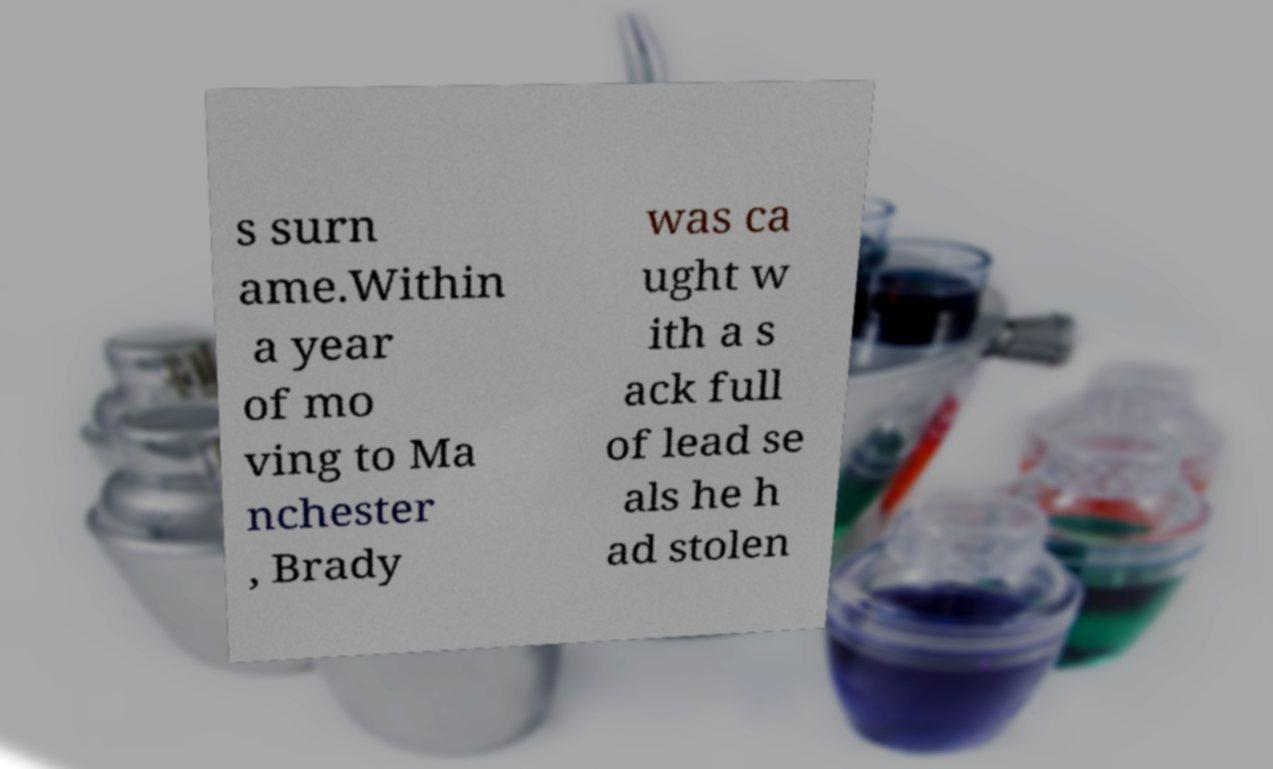Please read and relay the text visible in this image. What does it say? s surn ame.Within a year of mo ving to Ma nchester , Brady was ca ught w ith a s ack full of lead se als he h ad stolen 